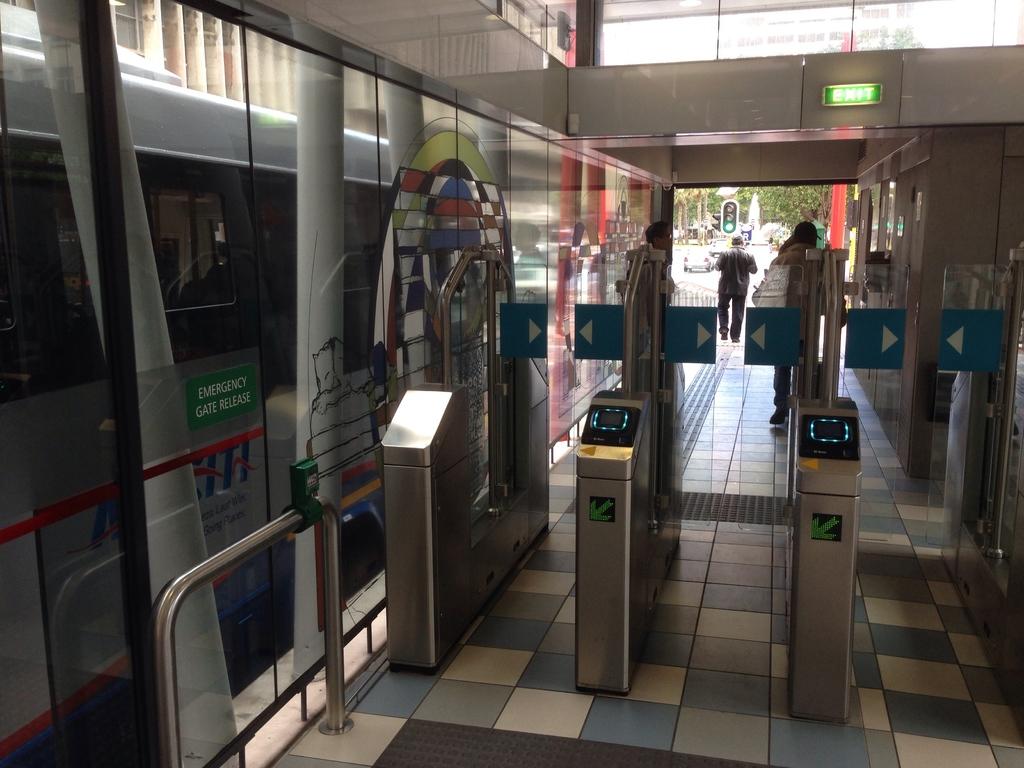What is on the green sticker?
Provide a succinct answer. Emergency gate release. Is this an entrance or an exit?
Give a very brief answer. Exit. 